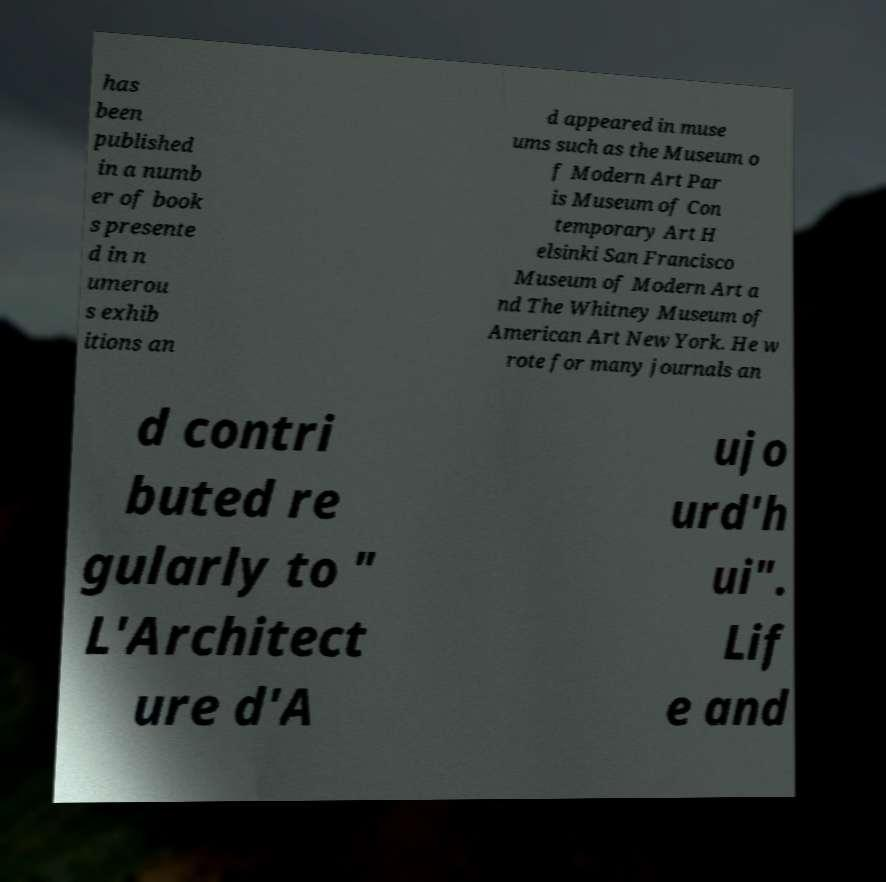Can you accurately transcribe the text from the provided image for me? has been published in a numb er of book s presente d in n umerou s exhib itions an d appeared in muse ums such as the Museum o f Modern Art Par is Museum of Con temporary Art H elsinki San Francisco Museum of Modern Art a nd The Whitney Museum of American Art New York. He w rote for many journals an d contri buted re gularly to " L'Architect ure d'A ujo urd'h ui". Lif e and 